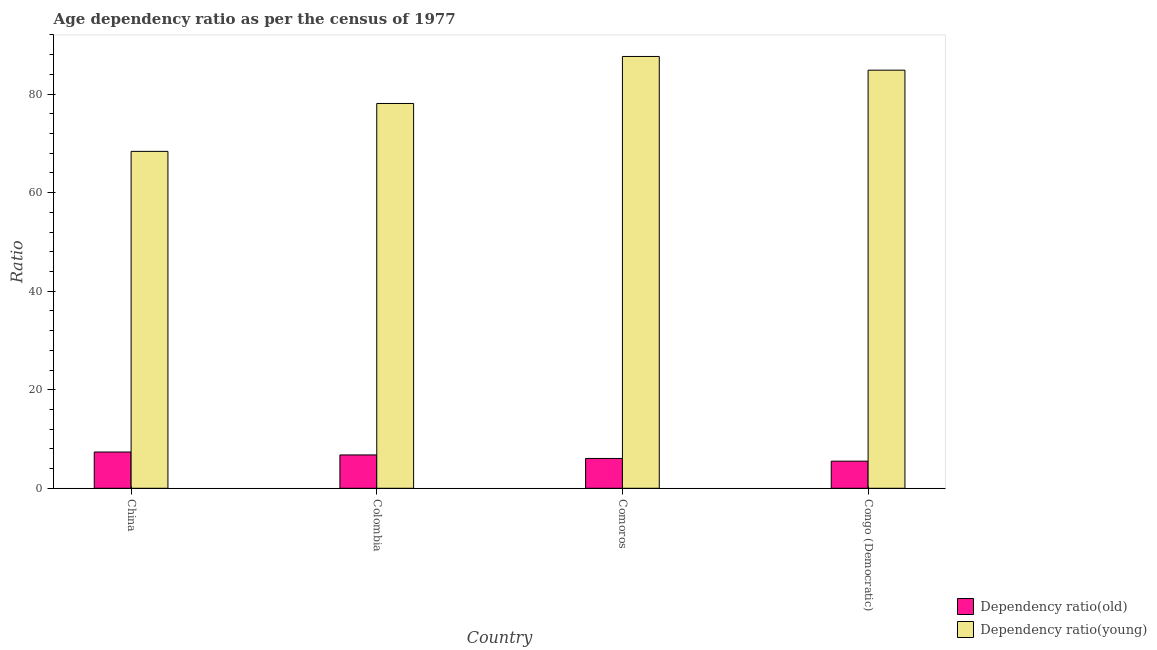Are the number of bars on each tick of the X-axis equal?
Your answer should be very brief. Yes. How many bars are there on the 2nd tick from the left?
Your answer should be very brief. 2. What is the label of the 4th group of bars from the left?
Provide a short and direct response. Congo (Democratic). What is the age dependency ratio(old) in Congo (Democratic)?
Your answer should be very brief. 5.5. Across all countries, what is the maximum age dependency ratio(young)?
Provide a short and direct response. 87.63. Across all countries, what is the minimum age dependency ratio(old)?
Offer a terse response. 5.5. In which country was the age dependency ratio(old) maximum?
Keep it short and to the point. China. What is the total age dependency ratio(young) in the graph?
Offer a very short reply. 318.94. What is the difference between the age dependency ratio(old) in Colombia and that in Comoros?
Provide a short and direct response. 0.71. What is the difference between the age dependency ratio(young) in China and the age dependency ratio(old) in Colombia?
Make the answer very short. 61.61. What is the average age dependency ratio(old) per country?
Offer a terse response. 6.42. What is the difference between the age dependency ratio(old) and age dependency ratio(young) in Congo (Democratic)?
Keep it short and to the point. -79.35. In how many countries, is the age dependency ratio(young) greater than 24 ?
Provide a succinct answer. 4. What is the ratio of the age dependency ratio(young) in China to that in Congo (Democratic)?
Ensure brevity in your answer.  0.81. Is the age dependency ratio(young) in China less than that in Congo (Democratic)?
Ensure brevity in your answer.  Yes. Is the difference between the age dependency ratio(old) in China and Congo (Democratic) greater than the difference between the age dependency ratio(young) in China and Congo (Democratic)?
Give a very brief answer. Yes. What is the difference between the highest and the second highest age dependency ratio(young)?
Make the answer very short. 2.78. What is the difference between the highest and the lowest age dependency ratio(young)?
Offer a very short reply. 19.26. In how many countries, is the age dependency ratio(young) greater than the average age dependency ratio(young) taken over all countries?
Keep it short and to the point. 2. What does the 2nd bar from the left in Comoros represents?
Offer a very short reply. Dependency ratio(young). What does the 2nd bar from the right in Colombia represents?
Ensure brevity in your answer.  Dependency ratio(old). Are all the bars in the graph horizontal?
Keep it short and to the point. No. Does the graph contain any zero values?
Provide a short and direct response. No. Does the graph contain grids?
Provide a short and direct response. No. What is the title of the graph?
Offer a terse response. Age dependency ratio as per the census of 1977. Does "Urban agglomerations" appear as one of the legend labels in the graph?
Ensure brevity in your answer.  No. What is the label or title of the X-axis?
Ensure brevity in your answer.  Country. What is the label or title of the Y-axis?
Provide a short and direct response. Ratio. What is the Ratio in Dependency ratio(old) in China?
Provide a short and direct response. 7.36. What is the Ratio of Dependency ratio(young) in China?
Provide a short and direct response. 68.37. What is the Ratio in Dependency ratio(old) in Colombia?
Offer a terse response. 6.77. What is the Ratio in Dependency ratio(young) in Colombia?
Your response must be concise. 78.09. What is the Ratio of Dependency ratio(old) in Comoros?
Your answer should be compact. 6.05. What is the Ratio in Dependency ratio(young) in Comoros?
Your answer should be very brief. 87.63. What is the Ratio of Dependency ratio(old) in Congo (Democratic)?
Provide a succinct answer. 5.5. What is the Ratio of Dependency ratio(young) in Congo (Democratic)?
Offer a terse response. 84.85. Across all countries, what is the maximum Ratio of Dependency ratio(old)?
Provide a short and direct response. 7.36. Across all countries, what is the maximum Ratio in Dependency ratio(young)?
Make the answer very short. 87.63. Across all countries, what is the minimum Ratio in Dependency ratio(old)?
Offer a terse response. 5.5. Across all countries, what is the minimum Ratio of Dependency ratio(young)?
Offer a terse response. 68.37. What is the total Ratio of Dependency ratio(old) in the graph?
Keep it short and to the point. 25.68. What is the total Ratio of Dependency ratio(young) in the graph?
Offer a very short reply. 318.94. What is the difference between the Ratio in Dependency ratio(old) in China and that in Colombia?
Offer a very short reply. 0.59. What is the difference between the Ratio of Dependency ratio(young) in China and that in Colombia?
Your answer should be compact. -9.72. What is the difference between the Ratio of Dependency ratio(old) in China and that in Comoros?
Give a very brief answer. 1.31. What is the difference between the Ratio in Dependency ratio(young) in China and that in Comoros?
Provide a short and direct response. -19.26. What is the difference between the Ratio of Dependency ratio(old) in China and that in Congo (Democratic)?
Give a very brief answer. 1.86. What is the difference between the Ratio of Dependency ratio(young) in China and that in Congo (Democratic)?
Provide a short and direct response. -16.48. What is the difference between the Ratio in Dependency ratio(old) in Colombia and that in Comoros?
Offer a terse response. 0.71. What is the difference between the Ratio in Dependency ratio(young) in Colombia and that in Comoros?
Your response must be concise. -9.54. What is the difference between the Ratio in Dependency ratio(old) in Colombia and that in Congo (Democratic)?
Offer a very short reply. 1.26. What is the difference between the Ratio of Dependency ratio(young) in Colombia and that in Congo (Democratic)?
Keep it short and to the point. -6.76. What is the difference between the Ratio in Dependency ratio(old) in Comoros and that in Congo (Democratic)?
Your answer should be very brief. 0.55. What is the difference between the Ratio in Dependency ratio(young) in Comoros and that in Congo (Democratic)?
Provide a succinct answer. 2.78. What is the difference between the Ratio in Dependency ratio(old) in China and the Ratio in Dependency ratio(young) in Colombia?
Your answer should be compact. -70.73. What is the difference between the Ratio of Dependency ratio(old) in China and the Ratio of Dependency ratio(young) in Comoros?
Your response must be concise. -80.27. What is the difference between the Ratio in Dependency ratio(old) in China and the Ratio in Dependency ratio(young) in Congo (Democratic)?
Your answer should be very brief. -77.49. What is the difference between the Ratio in Dependency ratio(old) in Colombia and the Ratio in Dependency ratio(young) in Comoros?
Offer a very short reply. -80.86. What is the difference between the Ratio of Dependency ratio(old) in Colombia and the Ratio of Dependency ratio(young) in Congo (Democratic)?
Your response must be concise. -78.08. What is the difference between the Ratio of Dependency ratio(old) in Comoros and the Ratio of Dependency ratio(young) in Congo (Democratic)?
Offer a very short reply. -78.8. What is the average Ratio of Dependency ratio(old) per country?
Offer a terse response. 6.42. What is the average Ratio in Dependency ratio(young) per country?
Ensure brevity in your answer.  79.73. What is the difference between the Ratio of Dependency ratio(old) and Ratio of Dependency ratio(young) in China?
Ensure brevity in your answer.  -61.01. What is the difference between the Ratio of Dependency ratio(old) and Ratio of Dependency ratio(young) in Colombia?
Give a very brief answer. -71.32. What is the difference between the Ratio in Dependency ratio(old) and Ratio in Dependency ratio(young) in Comoros?
Your answer should be compact. -81.58. What is the difference between the Ratio in Dependency ratio(old) and Ratio in Dependency ratio(young) in Congo (Democratic)?
Offer a very short reply. -79.35. What is the ratio of the Ratio of Dependency ratio(old) in China to that in Colombia?
Provide a short and direct response. 1.09. What is the ratio of the Ratio of Dependency ratio(young) in China to that in Colombia?
Your answer should be very brief. 0.88. What is the ratio of the Ratio of Dependency ratio(old) in China to that in Comoros?
Ensure brevity in your answer.  1.22. What is the ratio of the Ratio in Dependency ratio(young) in China to that in Comoros?
Ensure brevity in your answer.  0.78. What is the ratio of the Ratio of Dependency ratio(old) in China to that in Congo (Democratic)?
Give a very brief answer. 1.34. What is the ratio of the Ratio of Dependency ratio(young) in China to that in Congo (Democratic)?
Make the answer very short. 0.81. What is the ratio of the Ratio of Dependency ratio(old) in Colombia to that in Comoros?
Your response must be concise. 1.12. What is the ratio of the Ratio in Dependency ratio(young) in Colombia to that in Comoros?
Your answer should be compact. 0.89. What is the ratio of the Ratio in Dependency ratio(old) in Colombia to that in Congo (Democratic)?
Your response must be concise. 1.23. What is the ratio of the Ratio in Dependency ratio(young) in Colombia to that in Congo (Democratic)?
Your answer should be very brief. 0.92. What is the ratio of the Ratio in Dependency ratio(old) in Comoros to that in Congo (Democratic)?
Give a very brief answer. 1.1. What is the ratio of the Ratio in Dependency ratio(young) in Comoros to that in Congo (Democratic)?
Your response must be concise. 1.03. What is the difference between the highest and the second highest Ratio of Dependency ratio(old)?
Provide a short and direct response. 0.59. What is the difference between the highest and the second highest Ratio of Dependency ratio(young)?
Offer a very short reply. 2.78. What is the difference between the highest and the lowest Ratio in Dependency ratio(old)?
Provide a succinct answer. 1.86. What is the difference between the highest and the lowest Ratio in Dependency ratio(young)?
Provide a short and direct response. 19.26. 